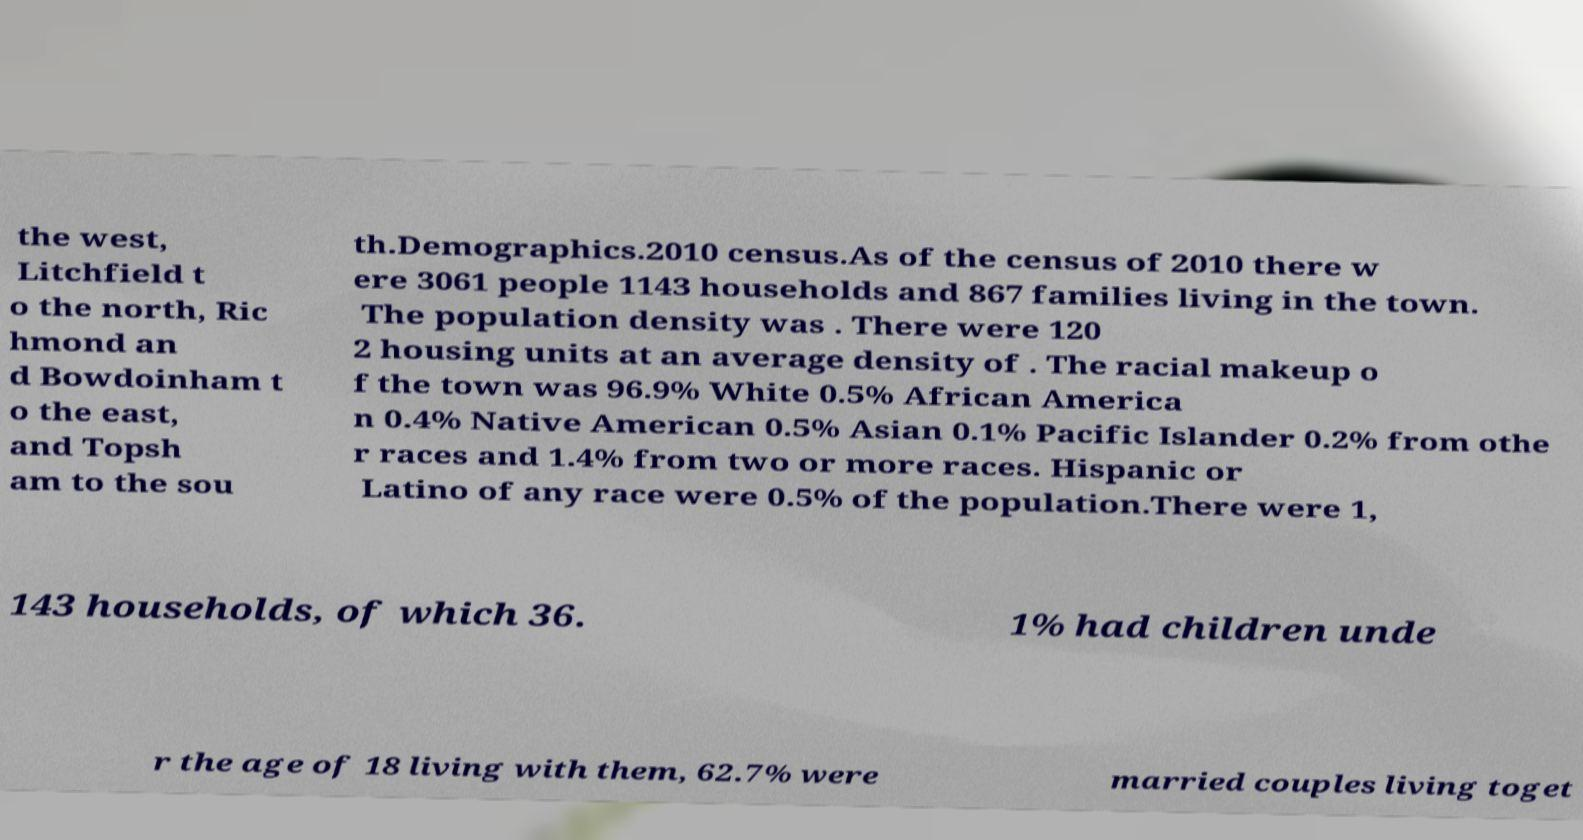Can you read and provide the text displayed in the image?This photo seems to have some interesting text. Can you extract and type it out for me? the west, Litchfield t o the north, Ric hmond an d Bowdoinham t o the east, and Topsh am to the sou th.Demographics.2010 census.As of the census of 2010 there w ere 3061 people 1143 households and 867 families living in the town. The population density was . There were 120 2 housing units at an average density of . The racial makeup o f the town was 96.9% White 0.5% African America n 0.4% Native American 0.5% Asian 0.1% Pacific Islander 0.2% from othe r races and 1.4% from two or more races. Hispanic or Latino of any race were 0.5% of the population.There were 1, 143 households, of which 36. 1% had children unde r the age of 18 living with them, 62.7% were married couples living toget 